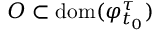Convert formula to latex. <formula><loc_0><loc_0><loc_500><loc_500>O \subset d o m ( \varphi _ { t _ { 0 } } ^ { \tau } )</formula> 